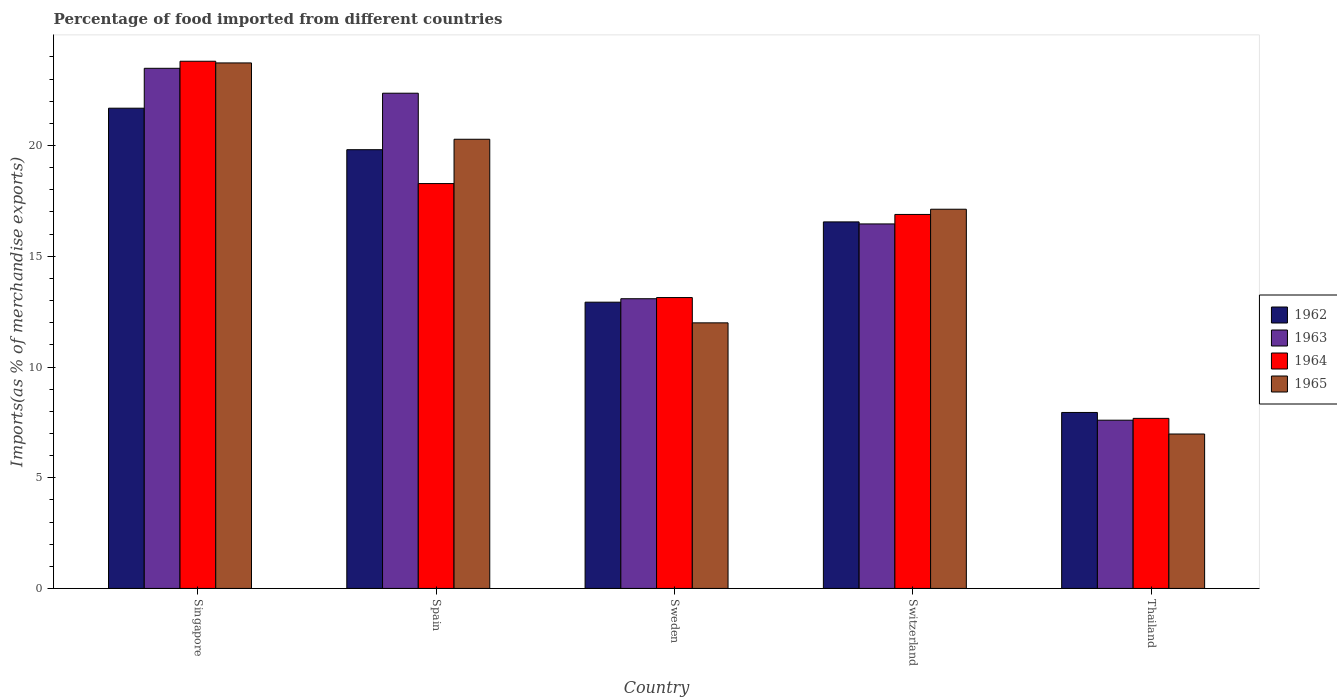Are the number of bars on each tick of the X-axis equal?
Provide a short and direct response. Yes. How many bars are there on the 3rd tick from the right?
Make the answer very short. 4. What is the label of the 1st group of bars from the left?
Provide a succinct answer. Singapore. What is the percentage of imports to different countries in 1963 in Spain?
Offer a terse response. 22.36. Across all countries, what is the maximum percentage of imports to different countries in 1965?
Keep it short and to the point. 23.73. Across all countries, what is the minimum percentage of imports to different countries in 1965?
Make the answer very short. 6.97. In which country was the percentage of imports to different countries in 1963 maximum?
Keep it short and to the point. Singapore. In which country was the percentage of imports to different countries in 1964 minimum?
Offer a very short reply. Thailand. What is the total percentage of imports to different countries in 1964 in the graph?
Your answer should be very brief. 79.8. What is the difference between the percentage of imports to different countries in 1963 in Switzerland and that in Thailand?
Your answer should be very brief. 8.86. What is the difference between the percentage of imports to different countries in 1965 in Switzerland and the percentage of imports to different countries in 1963 in Singapore?
Your response must be concise. -6.36. What is the average percentage of imports to different countries in 1964 per country?
Offer a terse response. 15.96. What is the difference between the percentage of imports to different countries of/in 1964 and percentage of imports to different countries of/in 1965 in Sweden?
Give a very brief answer. 1.14. What is the ratio of the percentage of imports to different countries in 1962 in Spain to that in Sweden?
Ensure brevity in your answer.  1.53. Is the percentage of imports to different countries in 1965 in Spain less than that in Sweden?
Give a very brief answer. No. Is the difference between the percentage of imports to different countries in 1964 in Singapore and Spain greater than the difference between the percentage of imports to different countries in 1965 in Singapore and Spain?
Your answer should be very brief. Yes. What is the difference between the highest and the second highest percentage of imports to different countries in 1965?
Keep it short and to the point. -3.16. What is the difference between the highest and the lowest percentage of imports to different countries in 1965?
Your answer should be very brief. 16.76. In how many countries, is the percentage of imports to different countries in 1962 greater than the average percentage of imports to different countries in 1962 taken over all countries?
Offer a very short reply. 3. Is the sum of the percentage of imports to different countries in 1963 in Switzerland and Thailand greater than the maximum percentage of imports to different countries in 1965 across all countries?
Your answer should be very brief. Yes. Is it the case that in every country, the sum of the percentage of imports to different countries in 1965 and percentage of imports to different countries in 1964 is greater than the sum of percentage of imports to different countries in 1963 and percentage of imports to different countries in 1962?
Your answer should be compact. No. What does the 3rd bar from the left in Sweden represents?
Make the answer very short. 1964. What does the 2nd bar from the right in Spain represents?
Give a very brief answer. 1964. Are all the bars in the graph horizontal?
Ensure brevity in your answer.  No. How many countries are there in the graph?
Provide a succinct answer. 5. What is the difference between two consecutive major ticks on the Y-axis?
Ensure brevity in your answer.  5. Are the values on the major ticks of Y-axis written in scientific E-notation?
Provide a succinct answer. No. Does the graph contain any zero values?
Give a very brief answer. No. How many legend labels are there?
Make the answer very short. 4. What is the title of the graph?
Ensure brevity in your answer.  Percentage of food imported from different countries. What is the label or title of the X-axis?
Offer a terse response. Country. What is the label or title of the Y-axis?
Offer a terse response. Imports(as % of merchandise exports). What is the Imports(as % of merchandise exports) of 1962 in Singapore?
Offer a very short reply. 21.69. What is the Imports(as % of merchandise exports) of 1963 in Singapore?
Provide a short and direct response. 23.49. What is the Imports(as % of merchandise exports) in 1964 in Singapore?
Offer a very short reply. 23.81. What is the Imports(as % of merchandise exports) in 1965 in Singapore?
Ensure brevity in your answer.  23.73. What is the Imports(as % of merchandise exports) of 1962 in Spain?
Ensure brevity in your answer.  19.81. What is the Imports(as % of merchandise exports) of 1963 in Spain?
Give a very brief answer. 22.36. What is the Imports(as % of merchandise exports) of 1964 in Spain?
Provide a succinct answer. 18.28. What is the Imports(as % of merchandise exports) of 1965 in Spain?
Your answer should be very brief. 20.28. What is the Imports(as % of merchandise exports) of 1962 in Sweden?
Offer a terse response. 12.93. What is the Imports(as % of merchandise exports) in 1963 in Sweden?
Keep it short and to the point. 13.08. What is the Imports(as % of merchandise exports) in 1964 in Sweden?
Offer a terse response. 13.14. What is the Imports(as % of merchandise exports) of 1965 in Sweden?
Offer a very short reply. 11.99. What is the Imports(as % of merchandise exports) in 1962 in Switzerland?
Offer a very short reply. 16.55. What is the Imports(as % of merchandise exports) of 1963 in Switzerland?
Make the answer very short. 16.46. What is the Imports(as % of merchandise exports) in 1964 in Switzerland?
Give a very brief answer. 16.89. What is the Imports(as % of merchandise exports) in 1965 in Switzerland?
Offer a terse response. 17.12. What is the Imports(as % of merchandise exports) of 1962 in Thailand?
Keep it short and to the point. 7.95. What is the Imports(as % of merchandise exports) in 1963 in Thailand?
Your answer should be compact. 7.6. What is the Imports(as % of merchandise exports) in 1964 in Thailand?
Provide a succinct answer. 7.68. What is the Imports(as % of merchandise exports) of 1965 in Thailand?
Ensure brevity in your answer.  6.97. Across all countries, what is the maximum Imports(as % of merchandise exports) in 1962?
Your response must be concise. 21.69. Across all countries, what is the maximum Imports(as % of merchandise exports) of 1963?
Your answer should be compact. 23.49. Across all countries, what is the maximum Imports(as % of merchandise exports) of 1964?
Give a very brief answer. 23.81. Across all countries, what is the maximum Imports(as % of merchandise exports) of 1965?
Make the answer very short. 23.73. Across all countries, what is the minimum Imports(as % of merchandise exports) of 1962?
Give a very brief answer. 7.95. Across all countries, what is the minimum Imports(as % of merchandise exports) of 1963?
Your response must be concise. 7.6. Across all countries, what is the minimum Imports(as % of merchandise exports) in 1964?
Give a very brief answer. 7.68. Across all countries, what is the minimum Imports(as % of merchandise exports) in 1965?
Your answer should be compact. 6.97. What is the total Imports(as % of merchandise exports) of 1962 in the graph?
Offer a terse response. 78.93. What is the total Imports(as % of merchandise exports) in 1963 in the graph?
Your response must be concise. 83. What is the total Imports(as % of merchandise exports) of 1964 in the graph?
Your response must be concise. 79.8. What is the total Imports(as % of merchandise exports) in 1965 in the graph?
Provide a short and direct response. 80.11. What is the difference between the Imports(as % of merchandise exports) of 1962 in Singapore and that in Spain?
Ensure brevity in your answer.  1.87. What is the difference between the Imports(as % of merchandise exports) in 1963 in Singapore and that in Spain?
Your answer should be compact. 1.12. What is the difference between the Imports(as % of merchandise exports) of 1964 in Singapore and that in Spain?
Provide a succinct answer. 5.52. What is the difference between the Imports(as % of merchandise exports) of 1965 in Singapore and that in Spain?
Ensure brevity in your answer.  3.45. What is the difference between the Imports(as % of merchandise exports) of 1962 in Singapore and that in Sweden?
Ensure brevity in your answer.  8.76. What is the difference between the Imports(as % of merchandise exports) of 1963 in Singapore and that in Sweden?
Your answer should be very brief. 10.41. What is the difference between the Imports(as % of merchandise exports) in 1964 in Singapore and that in Sweden?
Provide a succinct answer. 10.67. What is the difference between the Imports(as % of merchandise exports) in 1965 in Singapore and that in Sweden?
Your answer should be very brief. 11.74. What is the difference between the Imports(as % of merchandise exports) of 1962 in Singapore and that in Switzerland?
Your answer should be compact. 5.13. What is the difference between the Imports(as % of merchandise exports) in 1963 in Singapore and that in Switzerland?
Ensure brevity in your answer.  7.03. What is the difference between the Imports(as % of merchandise exports) of 1964 in Singapore and that in Switzerland?
Make the answer very short. 6.92. What is the difference between the Imports(as % of merchandise exports) in 1965 in Singapore and that in Switzerland?
Your response must be concise. 6.61. What is the difference between the Imports(as % of merchandise exports) in 1962 in Singapore and that in Thailand?
Make the answer very short. 13.74. What is the difference between the Imports(as % of merchandise exports) of 1963 in Singapore and that in Thailand?
Offer a terse response. 15.89. What is the difference between the Imports(as % of merchandise exports) of 1964 in Singapore and that in Thailand?
Provide a succinct answer. 16.13. What is the difference between the Imports(as % of merchandise exports) of 1965 in Singapore and that in Thailand?
Keep it short and to the point. 16.76. What is the difference between the Imports(as % of merchandise exports) in 1962 in Spain and that in Sweden?
Keep it short and to the point. 6.89. What is the difference between the Imports(as % of merchandise exports) of 1963 in Spain and that in Sweden?
Your response must be concise. 9.28. What is the difference between the Imports(as % of merchandise exports) of 1964 in Spain and that in Sweden?
Offer a terse response. 5.15. What is the difference between the Imports(as % of merchandise exports) of 1965 in Spain and that in Sweden?
Your answer should be very brief. 8.29. What is the difference between the Imports(as % of merchandise exports) in 1962 in Spain and that in Switzerland?
Give a very brief answer. 3.26. What is the difference between the Imports(as % of merchandise exports) of 1963 in Spain and that in Switzerland?
Offer a very short reply. 5.9. What is the difference between the Imports(as % of merchandise exports) of 1964 in Spain and that in Switzerland?
Keep it short and to the point. 1.39. What is the difference between the Imports(as % of merchandise exports) in 1965 in Spain and that in Switzerland?
Your answer should be very brief. 3.16. What is the difference between the Imports(as % of merchandise exports) of 1962 in Spain and that in Thailand?
Offer a terse response. 11.87. What is the difference between the Imports(as % of merchandise exports) of 1963 in Spain and that in Thailand?
Make the answer very short. 14.77. What is the difference between the Imports(as % of merchandise exports) of 1964 in Spain and that in Thailand?
Your response must be concise. 10.6. What is the difference between the Imports(as % of merchandise exports) in 1965 in Spain and that in Thailand?
Your answer should be very brief. 13.31. What is the difference between the Imports(as % of merchandise exports) of 1962 in Sweden and that in Switzerland?
Provide a succinct answer. -3.63. What is the difference between the Imports(as % of merchandise exports) of 1963 in Sweden and that in Switzerland?
Offer a terse response. -3.38. What is the difference between the Imports(as % of merchandise exports) of 1964 in Sweden and that in Switzerland?
Provide a short and direct response. -3.75. What is the difference between the Imports(as % of merchandise exports) in 1965 in Sweden and that in Switzerland?
Provide a short and direct response. -5.13. What is the difference between the Imports(as % of merchandise exports) in 1962 in Sweden and that in Thailand?
Provide a short and direct response. 4.98. What is the difference between the Imports(as % of merchandise exports) of 1963 in Sweden and that in Thailand?
Ensure brevity in your answer.  5.49. What is the difference between the Imports(as % of merchandise exports) in 1964 in Sweden and that in Thailand?
Provide a short and direct response. 5.46. What is the difference between the Imports(as % of merchandise exports) in 1965 in Sweden and that in Thailand?
Keep it short and to the point. 5.02. What is the difference between the Imports(as % of merchandise exports) of 1962 in Switzerland and that in Thailand?
Your answer should be compact. 8.61. What is the difference between the Imports(as % of merchandise exports) of 1963 in Switzerland and that in Thailand?
Offer a terse response. 8.86. What is the difference between the Imports(as % of merchandise exports) in 1964 in Switzerland and that in Thailand?
Make the answer very short. 9.21. What is the difference between the Imports(as % of merchandise exports) of 1965 in Switzerland and that in Thailand?
Make the answer very short. 10.15. What is the difference between the Imports(as % of merchandise exports) in 1962 in Singapore and the Imports(as % of merchandise exports) in 1963 in Spain?
Provide a short and direct response. -0.68. What is the difference between the Imports(as % of merchandise exports) in 1962 in Singapore and the Imports(as % of merchandise exports) in 1964 in Spain?
Your response must be concise. 3.4. What is the difference between the Imports(as % of merchandise exports) in 1962 in Singapore and the Imports(as % of merchandise exports) in 1965 in Spain?
Provide a succinct answer. 1.4. What is the difference between the Imports(as % of merchandise exports) in 1963 in Singapore and the Imports(as % of merchandise exports) in 1964 in Spain?
Give a very brief answer. 5.21. What is the difference between the Imports(as % of merchandise exports) of 1963 in Singapore and the Imports(as % of merchandise exports) of 1965 in Spain?
Offer a very short reply. 3.2. What is the difference between the Imports(as % of merchandise exports) of 1964 in Singapore and the Imports(as % of merchandise exports) of 1965 in Spain?
Your response must be concise. 3.52. What is the difference between the Imports(as % of merchandise exports) of 1962 in Singapore and the Imports(as % of merchandise exports) of 1963 in Sweden?
Ensure brevity in your answer.  8.6. What is the difference between the Imports(as % of merchandise exports) in 1962 in Singapore and the Imports(as % of merchandise exports) in 1964 in Sweden?
Provide a short and direct response. 8.55. What is the difference between the Imports(as % of merchandise exports) in 1962 in Singapore and the Imports(as % of merchandise exports) in 1965 in Sweden?
Your answer should be compact. 9.69. What is the difference between the Imports(as % of merchandise exports) in 1963 in Singapore and the Imports(as % of merchandise exports) in 1964 in Sweden?
Your answer should be compact. 10.35. What is the difference between the Imports(as % of merchandise exports) of 1963 in Singapore and the Imports(as % of merchandise exports) of 1965 in Sweden?
Keep it short and to the point. 11.5. What is the difference between the Imports(as % of merchandise exports) in 1964 in Singapore and the Imports(as % of merchandise exports) in 1965 in Sweden?
Give a very brief answer. 11.81. What is the difference between the Imports(as % of merchandise exports) in 1962 in Singapore and the Imports(as % of merchandise exports) in 1963 in Switzerland?
Provide a short and direct response. 5.23. What is the difference between the Imports(as % of merchandise exports) of 1962 in Singapore and the Imports(as % of merchandise exports) of 1964 in Switzerland?
Keep it short and to the point. 4.8. What is the difference between the Imports(as % of merchandise exports) of 1962 in Singapore and the Imports(as % of merchandise exports) of 1965 in Switzerland?
Give a very brief answer. 4.56. What is the difference between the Imports(as % of merchandise exports) of 1963 in Singapore and the Imports(as % of merchandise exports) of 1964 in Switzerland?
Ensure brevity in your answer.  6.6. What is the difference between the Imports(as % of merchandise exports) in 1963 in Singapore and the Imports(as % of merchandise exports) in 1965 in Switzerland?
Provide a short and direct response. 6.36. What is the difference between the Imports(as % of merchandise exports) of 1964 in Singapore and the Imports(as % of merchandise exports) of 1965 in Switzerland?
Ensure brevity in your answer.  6.68. What is the difference between the Imports(as % of merchandise exports) in 1962 in Singapore and the Imports(as % of merchandise exports) in 1963 in Thailand?
Your response must be concise. 14.09. What is the difference between the Imports(as % of merchandise exports) in 1962 in Singapore and the Imports(as % of merchandise exports) in 1964 in Thailand?
Offer a very short reply. 14.01. What is the difference between the Imports(as % of merchandise exports) in 1962 in Singapore and the Imports(as % of merchandise exports) in 1965 in Thailand?
Give a very brief answer. 14.71. What is the difference between the Imports(as % of merchandise exports) of 1963 in Singapore and the Imports(as % of merchandise exports) of 1964 in Thailand?
Give a very brief answer. 15.81. What is the difference between the Imports(as % of merchandise exports) of 1963 in Singapore and the Imports(as % of merchandise exports) of 1965 in Thailand?
Your response must be concise. 16.52. What is the difference between the Imports(as % of merchandise exports) of 1964 in Singapore and the Imports(as % of merchandise exports) of 1965 in Thailand?
Provide a short and direct response. 16.83. What is the difference between the Imports(as % of merchandise exports) of 1962 in Spain and the Imports(as % of merchandise exports) of 1963 in Sweden?
Your answer should be compact. 6.73. What is the difference between the Imports(as % of merchandise exports) of 1962 in Spain and the Imports(as % of merchandise exports) of 1964 in Sweden?
Your answer should be compact. 6.68. What is the difference between the Imports(as % of merchandise exports) in 1962 in Spain and the Imports(as % of merchandise exports) in 1965 in Sweden?
Provide a succinct answer. 7.82. What is the difference between the Imports(as % of merchandise exports) in 1963 in Spain and the Imports(as % of merchandise exports) in 1964 in Sweden?
Your answer should be compact. 9.23. What is the difference between the Imports(as % of merchandise exports) of 1963 in Spain and the Imports(as % of merchandise exports) of 1965 in Sweden?
Your answer should be very brief. 10.37. What is the difference between the Imports(as % of merchandise exports) in 1964 in Spain and the Imports(as % of merchandise exports) in 1965 in Sweden?
Keep it short and to the point. 6.29. What is the difference between the Imports(as % of merchandise exports) in 1962 in Spain and the Imports(as % of merchandise exports) in 1963 in Switzerland?
Your answer should be very brief. 3.35. What is the difference between the Imports(as % of merchandise exports) in 1962 in Spain and the Imports(as % of merchandise exports) in 1964 in Switzerland?
Your response must be concise. 2.92. What is the difference between the Imports(as % of merchandise exports) of 1962 in Spain and the Imports(as % of merchandise exports) of 1965 in Switzerland?
Ensure brevity in your answer.  2.69. What is the difference between the Imports(as % of merchandise exports) in 1963 in Spain and the Imports(as % of merchandise exports) in 1964 in Switzerland?
Ensure brevity in your answer.  5.48. What is the difference between the Imports(as % of merchandise exports) of 1963 in Spain and the Imports(as % of merchandise exports) of 1965 in Switzerland?
Provide a succinct answer. 5.24. What is the difference between the Imports(as % of merchandise exports) in 1964 in Spain and the Imports(as % of merchandise exports) in 1965 in Switzerland?
Ensure brevity in your answer.  1.16. What is the difference between the Imports(as % of merchandise exports) of 1962 in Spain and the Imports(as % of merchandise exports) of 1963 in Thailand?
Your answer should be very brief. 12.22. What is the difference between the Imports(as % of merchandise exports) in 1962 in Spain and the Imports(as % of merchandise exports) in 1964 in Thailand?
Offer a terse response. 12.13. What is the difference between the Imports(as % of merchandise exports) in 1962 in Spain and the Imports(as % of merchandise exports) in 1965 in Thailand?
Make the answer very short. 12.84. What is the difference between the Imports(as % of merchandise exports) in 1963 in Spain and the Imports(as % of merchandise exports) in 1964 in Thailand?
Offer a very short reply. 14.68. What is the difference between the Imports(as % of merchandise exports) of 1963 in Spain and the Imports(as % of merchandise exports) of 1965 in Thailand?
Give a very brief answer. 15.39. What is the difference between the Imports(as % of merchandise exports) in 1964 in Spain and the Imports(as % of merchandise exports) in 1965 in Thailand?
Provide a succinct answer. 11.31. What is the difference between the Imports(as % of merchandise exports) of 1962 in Sweden and the Imports(as % of merchandise exports) of 1963 in Switzerland?
Your response must be concise. -3.53. What is the difference between the Imports(as % of merchandise exports) in 1962 in Sweden and the Imports(as % of merchandise exports) in 1964 in Switzerland?
Offer a terse response. -3.96. What is the difference between the Imports(as % of merchandise exports) in 1962 in Sweden and the Imports(as % of merchandise exports) in 1965 in Switzerland?
Ensure brevity in your answer.  -4.2. What is the difference between the Imports(as % of merchandise exports) of 1963 in Sweden and the Imports(as % of merchandise exports) of 1964 in Switzerland?
Provide a succinct answer. -3.81. What is the difference between the Imports(as % of merchandise exports) of 1963 in Sweden and the Imports(as % of merchandise exports) of 1965 in Switzerland?
Your answer should be compact. -4.04. What is the difference between the Imports(as % of merchandise exports) in 1964 in Sweden and the Imports(as % of merchandise exports) in 1965 in Switzerland?
Make the answer very short. -3.99. What is the difference between the Imports(as % of merchandise exports) of 1962 in Sweden and the Imports(as % of merchandise exports) of 1963 in Thailand?
Offer a terse response. 5.33. What is the difference between the Imports(as % of merchandise exports) of 1962 in Sweden and the Imports(as % of merchandise exports) of 1964 in Thailand?
Make the answer very short. 5.25. What is the difference between the Imports(as % of merchandise exports) of 1962 in Sweden and the Imports(as % of merchandise exports) of 1965 in Thailand?
Your response must be concise. 5.95. What is the difference between the Imports(as % of merchandise exports) of 1963 in Sweden and the Imports(as % of merchandise exports) of 1964 in Thailand?
Make the answer very short. 5.4. What is the difference between the Imports(as % of merchandise exports) in 1963 in Sweden and the Imports(as % of merchandise exports) in 1965 in Thailand?
Offer a terse response. 6.11. What is the difference between the Imports(as % of merchandise exports) of 1964 in Sweden and the Imports(as % of merchandise exports) of 1965 in Thailand?
Your response must be concise. 6.16. What is the difference between the Imports(as % of merchandise exports) of 1962 in Switzerland and the Imports(as % of merchandise exports) of 1963 in Thailand?
Your response must be concise. 8.96. What is the difference between the Imports(as % of merchandise exports) in 1962 in Switzerland and the Imports(as % of merchandise exports) in 1964 in Thailand?
Keep it short and to the point. 8.87. What is the difference between the Imports(as % of merchandise exports) of 1962 in Switzerland and the Imports(as % of merchandise exports) of 1965 in Thailand?
Keep it short and to the point. 9.58. What is the difference between the Imports(as % of merchandise exports) in 1963 in Switzerland and the Imports(as % of merchandise exports) in 1964 in Thailand?
Your response must be concise. 8.78. What is the difference between the Imports(as % of merchandise exports) in 1963 in Switzerland and the Imports(as % of merchandise exports) in 1965 in Thailand?
Provide a short and direct response. 9.49. What is the difference between the Imports(as % of merchandise exports) of 1964 in Switzerland and the Imports(as % of merchandise exports) of 1965 in Thailand?
Your answer should be very brief. 9.92. What is the average Imports(as % of merchandise exports) in 1962 per country?
Provide a succinct answer. 15.79. What is the average Imports(as % of merchandise exports) in 1963 per country?
Your answer should be very brief. 16.6. What is the average Imports(as % of merchandise exports) in 1964 per country?
Offer a very short reply. 15.96. What is the average Imports(as % of merchandise exports) of 1965 per country?
Your response must be concise. 16.02. What is the difference between the Imports(as % of merchandise exports) in 1962 and Imports(as % of merchandise exports) in 1963 in Singapore?
Make the answer very short. -1.8. What is the difference between the Imports(as % of merchandise exports) in 1962 and Imports(as % of merchandise exports) in 1964 in Singapore?
Offer a terse response. -2.12. What is the difference between the Imports(as % of merchandise exports) in 1962 and Imports(as % of merchandise exports) in 1965 in Singapore?
Your response must be concise. -2.04. What is the difference between the Imports(as % of merchandise exports) of 1963 and Imports(as % of merchandise exports) of 1964 in Singapore?
Provide a succinct answer. -0.32. What is the difference between the Imports(as % of merchandise exports) of 1963 and Imports(as % of merchandise exports) of 1965 in Singapore?
Provide a short and direct response. -0.24. What is the difference between the Imports(as % of merchandise exports) of 1964 and Imports(as % of merchandise exports) of 1965 in Singapore?
Ensure brevity in your answer.  0.08. What is the difference between the Imports(as % of merchandise exports) of 1962 and Imports(as % of merchandise exports) of 1963 in Spain?
Provide a succinct answer. -2.55. What is the difference between the Imports(as % of merchandise exports) in 1962 and Imports(as % of merchandise exports) in 1964 in Spain?
Provide a succinct answer. 1.53. What is the difference between the Imports(as % of merchandise exports) of 1962 and Imports(as % of merchandise exports) of 1965 in Spain?
Give a very brief answer. -0.47. What is the difference between the Imports(as % of merchandise exports) of 1963 and Imports(as % of merchandise exports) of 1964 in Spain?
Provide a succinct answer. 4.08. What is the difference between the Imports(as % of merchandise exports) of 1963 and Imports(as % of merchandise exports) of 1965 in Spain?
Ensure brevity in your answer.  2.08. What is the difference between the Imports(as % of merchandise exports) in 1964 and Imports(as % of merchandise exports) in 1965 in Spain?
Provide a succinct answer. -2. What is the difference between the Imports(as % of merchandise exports) in 1962 and Imports(as % of merchandise exports) in 1963 in Sweden?
Ensure brevity in your answer.  -0.16. What is the difference between the Imports(as % of merchandise exports) of 1962 and Imports(as % of merchandise exports) of 1964 in Sweden?
Provide a succinct answer. -0.21. What is the difference between the Imports(as % of merchandise exports) of 1962 and Imports(as % of merchandise exports) of 1965 in Sweden?
Give a very brief answer. 0.93. What is the difference between the Imports(as % of merchandise exports) of 1963 and Imports(as % of merchandise exports) of 1964 in Sweden?
Keep it short and to the point. -0.05. What is the difference between the Imports(as % of merchandise exports) in 1963 and Imports(as % of merchandise exports) in 1965 in Sweden?
Give a very brief answer. 1.09. What is the difference between the Imports(as % of merchandise exports) in 1964 and Imports(as % of merchandise exports) in 1965 in Sweden?
Offer a very short reply. 1.14. What is the difference between the Imports(as % of merchandise exports) of 1962 and Imports(as % of merchandise exports) of 1963 in Switzerland?
Give a very brief answer. 0.09. What is the difference between the Imports(as % of merchandise exports) in 1962 and Imports(as % of merchandise exports) in 1964 in Switzerland?
Give a very brief answer. -0.34. What is the difference between the Imports(as % of merchandise exports) in 1962 and Imports(as % of merchandise exports) in 1965 in Switzerland?
Provide a short and direct response. -0.57. What is the difference between the Imports(as % of merchandise exports) in 1963 and Imports(as % of merchandise exports) in 1964 in Switzerland?
Offer a very short reply. -0.43. What is the difference between the Imports(as % of merchandise exports) in 1963 and Imports(as % of merchandise exports) in 1965 in Switzerland?
Offer a terse response. -0.66. What is the difference between the Imports(as % of merchandise exports) of 1964 and Imports(as % of merchandise exports) of 1965 in Switzerland?
Make the answer very short. -0.24. What is the difference between the Imports(as % of merchandise exports) in 1962 and Imports(as % of merchandise exports) in 1963 in Thailand?
Provide a succinct answer. 0.35. What is the difference between the Imports(as % of merchandise exports) of 1962 and Imports(as % of merchandise exports) of 1964 in Thailand?
Provide a short and direct response. 0.27. What is the difference between the Imports(as % of merchandise exports) of 1962 and Imports(as % of merchandise exports) of 1965 in Thailand?
Give a very brief answer. 0.97. What is the difference between the Imports(as % of merchandise exports) in 1963 and Imports(as % of merchandise exports) in 1964 in Thailand?
Provide a succinct answer. -0.08. What is the difference between the Imports(as % of merchandise exports) in 1963 and Imports(as % of merchandise exports) in 1965 in Thailand?
Your answer should be compact. 0.62. What is the difference between the Imports(as % of merchandise exports) in 1964 and Imports(as % of merchandise exports) in 1965 in Thailand?
Offer a terse response. 0.71. What is the ratio of the Imports(as % of merchandise exports) of 1962 in Singapore to that in Spain?
Give a very brief answer. 1.09. What is the ratio of the Imports(as % of merchandise exports) in 1963 in Singapore to that in Spain?
Ensure brevity in your answer.  1.05. What is the ratio of the Imports(as % of merchandise exports) of 1964 in Singapore to that in Spain?
Give a very brief answer. 1.3. What is the ratio of the Imports(as % of merchandise exports) in 1965 in Singapore to that in Spain?
Give a very brief answer. 1.17. What is the ratio of the Imports(as % of merchandise exports) in 1962 in Singapore to that in Sweden?
Provide a succinct answer. 1.68. What is the ratio of the Imports(as % of merchandise exports) of 1963 in Singapore to that in Sweden?
Give a very brief answer. 1.8. What is the ratio of the Imports(as % of merchandise exports) of 1964 in Singapore to that in Sweden?
Give a very brief answer. 1.81. What is the ratio of the Imports(as % of merchandise exports) of 1965 in Singapore to that in Sweden?
Your answer should be compact. 1.98. What is the ratio of the Imports(as % of merchandise exports) of 1962 in Singapore to that in Switzerland?
Offer a very short reply. 1.31. What is the ratio of the Imports(as % of merchandise exports) in 1963 in Singapore to that in Switzerland?
Offer a very short reply. 1.43. What is the ratio of the Imports(as % of merchandise exports) in 1964 in Singapore to that in Switzerland?
Give a very brief answer. 1.41. What is the ratio of the Imports(as % of merchandise exports) of 1965 in Singapore to that in Switzerland?
Your answer should be very brief. 1.39. What is the ratio of the Imports(as % of merchandise exports) of 1962 in Singapore to that in Thailand?
Your response must be concise. 2.73. What is the ratio of the Imports(as % of merchandise exports) of 1963 in Singapore to that in Thailand?
Provide a short and direct response. 3.09. What is the ratio of the Imports(as % of merchandise exports) of 1964 in Singapore to that in Thailand?
Make the answer very short. 3.1. What is the ratio of the Imports(as % of merchandise exports) of 1965 in Singapore to that in Thailand?
Your answer should be very brief. 3.4. What is the ratio of the Imports(as % of merchandise exports) of 1962 in Spain to that in Sweden?
Ensure brevity in your answer.  1.53. What is the ratio of the Imports(as % of merchandise exports) in 1963 in Spain to that in Sweden?
Ensure brevity in your answer.  1.71. What is the ratio of the Imports(as % of merchandise exports) of 1964 in Spain to that in Sweden?
Your response must be concise. 1.39. What is the ratio of the Imports(as % of merchandise exports) of 1965 in Spain to that in Sweden?
Provide a succinct answer. 1.69. What is the ratio of the Imports(as % of merchandise exports) of 1962 in Spain to that in Switzerland?
Your response must be concise. 1.2. What is the ratio of the Imports(as % of merchandise exports) of 1963 in Spain to that in Switzerland?
Provide a succinct answer. 1.36. What is the ratio of the Imports(as % of merchandise exports) of 1964 in Spain to that in Switzerland?
Make the answer very short. 1.08. What is the ratio of the Imports(as % of merchandise exports) of 1965 in Spain to that in Switzerland?
Your answer should be very brief. 1.18. What is the ratio of the Imports(as % of merchandise exports) in 1962 in Spain to that in Thailand?
Provide a succinct answer. 2.49. What is the ratio of the Imports(as % of merchandise exports) in 1963 in Spain to that in Thailand?
Keep it short and to the point. 2.94. What is the ratio of the Imports(as % of merchandise exports) of 1964 in Spain to that in Thailand?
Your answer should be very brief. 2.38. What is the ratio of the Imports(as % of merchandise exports) in 1965 in Spain to that in Thailand?
Provide a short and direct response. 2.91. What is the ratio of the Imports(as % of merchandise exports) of 1962 in Sweden to that in Switzerland?
Provide a succinct answer. 0.78. What is the ratio of the Imports(as % of merchandise exports) of 1963 in Sweden to that in Switzerland?
Keep it short and to the point. 0.79. What is the ratio of the Imports(as % of merchandise exports) in 1965 in Sweden to that in Switzerland?
Keep it short and to the point. 0.7. What is the ratio of the Imports(as % of merchandise exports) of 1962 in Sweden to that in Thailand?
Give a very brief answer. 1.63. What is the ratio of the Imports(as % of merchandise exports) of 1963 in Sweden to that in Thailand?
Your answer should be compact. 1.72. What is the ratio of the Imports(as % of merchandise exports) in 1964 in Sweden to that in Thailand?
Provide a succinct answer. 1.71. What is the ratio of the Imports(as % of merchandise exports) of 1965 in Sweden to that in Thailand?
Offer a terse response. 1.72. What is the ratio of the Imports(as % of merchandise exports) in 1962 in Switzerland to that in Thailand?
Your response must be concise. 2.08. What is the ratio of the Imports(as % of merchandise exports) of 1963 in Switzerland to that in Thailand?
Make the answer very short. 2.17. What is the ratio of the Imports(as % of merchandise exports) of 1964 in Switzerland to that in Thailand?
Make the answer very short. 2.2. What is the ratio of the Imports(as % of merchandise exports) in 1965 in Switzerland to that in Thailand?
Offer a terse response. 2.46. What is the difference between the highest and the second highest Imports(as % of merchandise exports) in 1962?
Give a very brief answer. 1.87. What is the difference between the highest and the second highest Imports(as % of merchandise exports) in 1963?
Offer a very short reply. 1.12. What is the difference between the highest and the second highest Imports(as % of merchandise exports) in 1964?
Provide a succinct answer. 5.52. What is the difference between the highest and the second highest Imports(as % of merchandise exports) in 1965?
Give a very brief answer. 3.45. What is the difference between the highest and the lowest Imports(as % of merchandise exports) of 1962?
Your response must be concise. 13.74. What is the difference between the highest and the lowest Imports(as % of merchandise exports) of 1963?
Keep it short and to the point. 15.89. What is the difference between the highest and the lowest Imports(as % of merchandise exports) of 1964?
Your answer should be very brief. 16.13. What is the difference between the highest and the lowest Imports(as % of merchandise exports) of 1965?
Ensure brevity in your answer.  16.76. 